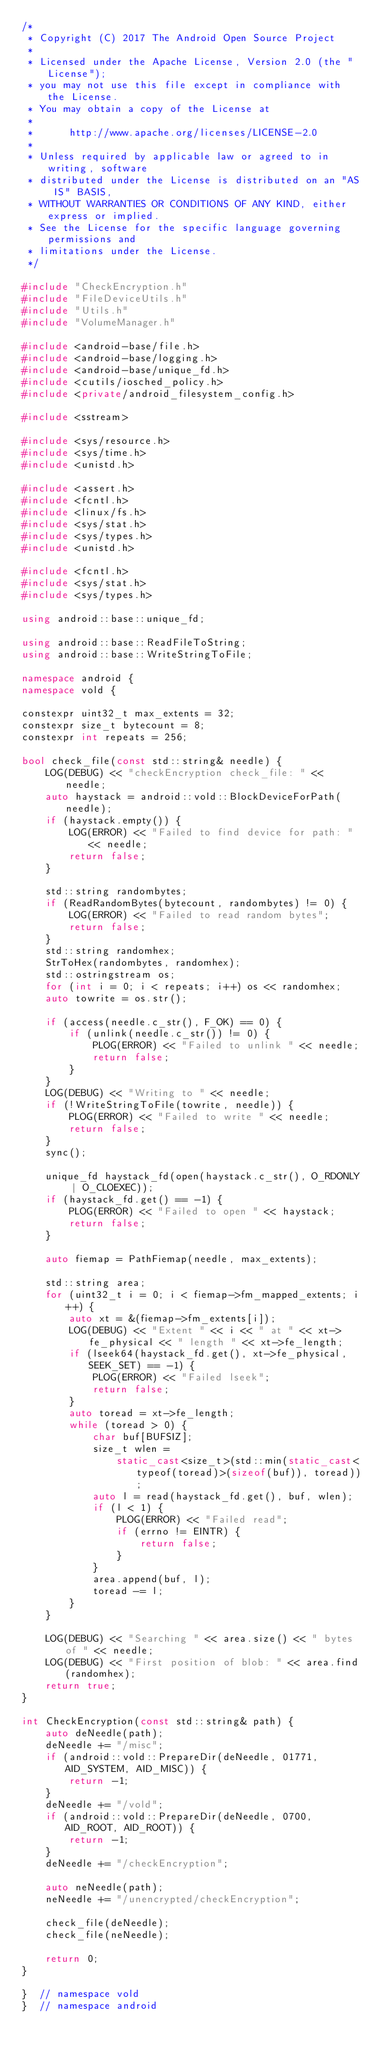Convert code to text. <code><loc_0><loc_0><loc_500><loc_500><_C++_>/*
 * Copyright (C) 2017 The Android Open Source Project
 *
 * Licensed under the Apache License, Version 2.0 (the "License");
 * you may not use this file except in compliance with the License.
 * You may obtain a copy of the License at
 *
 *      http://www.apache.org/licenses/LICENSE-2.0
 *
 * Unless required by applicable law or agreed to in writing, software
 * distributed under the License is distributed on an "AS IS" BASIS,
 * WITHOUT WARRANTIES OR CONDITIONS OF ANY KIND, either express or implied.
 * See the License for the specific language governing permissions and
 * limitations under the License.
 */

#include "CheckEncryption.h"
#include "FileDeviceUtils.h"
#include "Utils.h"
#include "VolumeManager.h"

#include <android-base/file.h>
#include <android-base/logging.h>
#include <android-base/unique_fd.h>
#include <cutils/iosched_policy.h>
#include <private/android_filesystem_config.h>

#include <sstream>

#include <sys/resource.h>
#include <sys/time.h>
#include <unistd.h>

#include <assert.h>
#include <fcntl.h>
#include <linux/fs.h>
#include <sys/stat.h>
#include <sys/types.h>
#include <unistd.h>

#include <fcntl.h>
#include <sys/stat.h>
#include <sys/types.h>

using android::base::unique_fd;

using android::base::ReadFileToString;
using android::base::WriteStringToFile;

namespace android {
namespace vold {

constexpr uint32_t max_extents = 32;
constexpr size_t bytecount = 8;
constexpr int repeats = 256;

bool check_file(const std::string& needle) {
    LOG(DEBUG) << "checkEncryption check_file: " << needle;
    auto haystack = android::vold::BlockDeviceForPath(needle);
    if (haystack.empty()) {
        LOG(ERROR) << "Failed to find device for path: " << needle;
        return false;
    }

    std::string randombytes;
    if (ReadRandomBytes(bytecount, randombytes) != 0) {
        LOG(ERROR) << "Failed to read random bytes";
        return false;
    }
    std::string randomhex;
    StrToHex(randombytes, randomhex);
    std::ostringstream os;
    for (int i = 0; i < repeats; i++) os << randomhex;
    auto towrite = os.str();

    if (access(needle.c_str(), F_OK) == 0) {
        if (unlink(needle.c_str()) != 0) {
            PLOG(ERROR) << "Failed to unlink " << needle;
            return false;
        }
    }
    LOG(DEBUG) << "Writing to " << needle;
    if (!WriteStringToFile(towrite, needle)) {
        PLOG(ERROR) << "Failed to write " << needle;
        return false;
    }
    sync();

    unique_fd haystack_fd(open(haystack.c_str(), O_RDONLY | O_CLOEXEC));
    if (haystack_fd.get() == -1) {
        PLOG(ERROR) << "Failed to open " << haystack;
        return false;
    }

    auto fiemap = PathFiemap(needle, max_extents);

    std::string area;
    for (uint32_t i = 0; i < fiemap->fm_mapped_extents; i++) {
        auto xt = &(fiemap->fm_extents[i]);
        LOG(DEBUG) << "Extent " << i << " at " << xt->fe_physical << " length " << xt->fe_length;
        if (lseek64(haystack_fd.get(), xt->fe_physical, SEEK_SET) == -1) {
            PLOG(ERROR) << "Failed lseek";
            return false;
        }
        auto toread = xt->fe_length;
        while (toread > 0) {
            char buf[BUFSIZ];
            size_t wlen =
                static_cast<size_t>(std::min(static_cast<typeof(toread)>(sizeof(buf)), toread));
            auto l = read(haystack_fd.get(), buf, wlen);
            if (l < 1) {
                PLOG(ERROR) << "Failed read";
                if (errno != EINTR) {
                    return false;
                }
            }
            area.append(buf, l);
            toread -= l;
        }
    }

    LOG(DEBUG) << "Searching " << area.size() << " bytes of " << needle;
    LOG(DEBUG) << "First position of blob: " << area.find(randomhex);
    return true;
}

int CheckEncryption(const std::string& path) {
    auto deNeedle(path);
    deNeedle += "/misc";
    if (android::vold::PrepareDir(deNeedle, 01771, AID_SYSTEM, AID_MISC)) {
        return -1;
    }
    deNeedle += "/vold";
    if (android::vold::PrepareDir(deNeedle, 0700, AID_ROOT, AID_ROOT)) {
        return -1;
    }
    deNeedle += "/checkEncryption";

    auto neNeedle(path);
    neNeedle += "/unencrypted/checkEncryption";

    check_file(deNeedle);
    check_file(neNeedle);

    return 0;
}

}  // namespace vold
}  // namespace android
</code> 